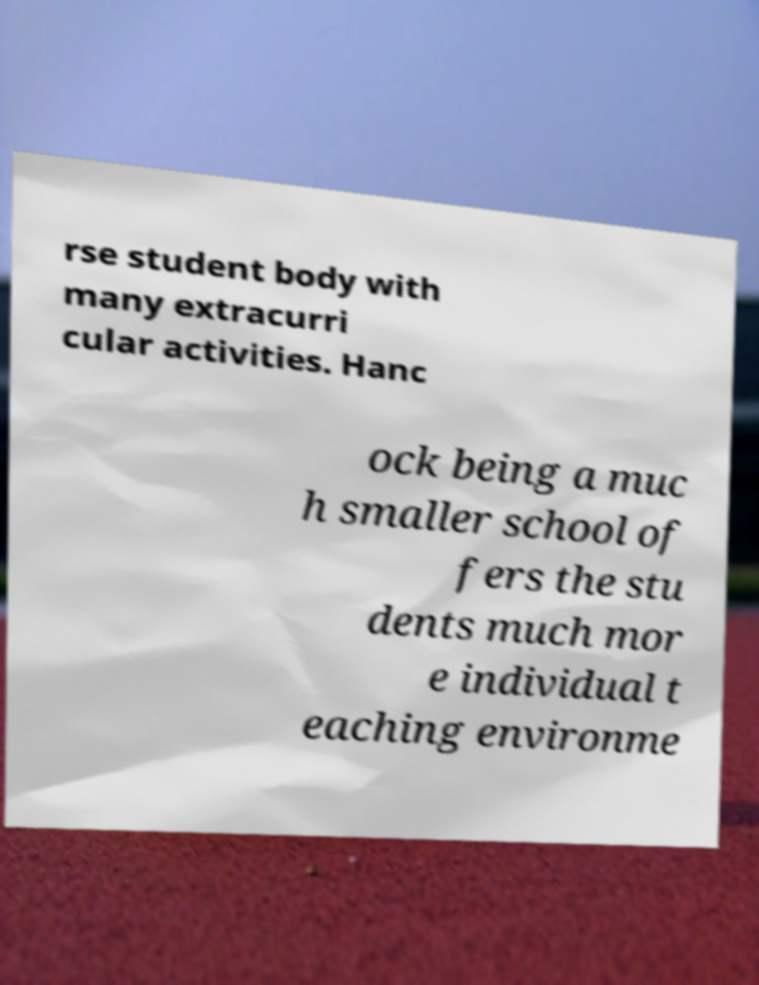Please identify and transcribe the text found in this image. rse student body with many extracurri cular activities. Hanc ock being a muc h smaller school of fers the stu dents much mor e individual t eaching environme 